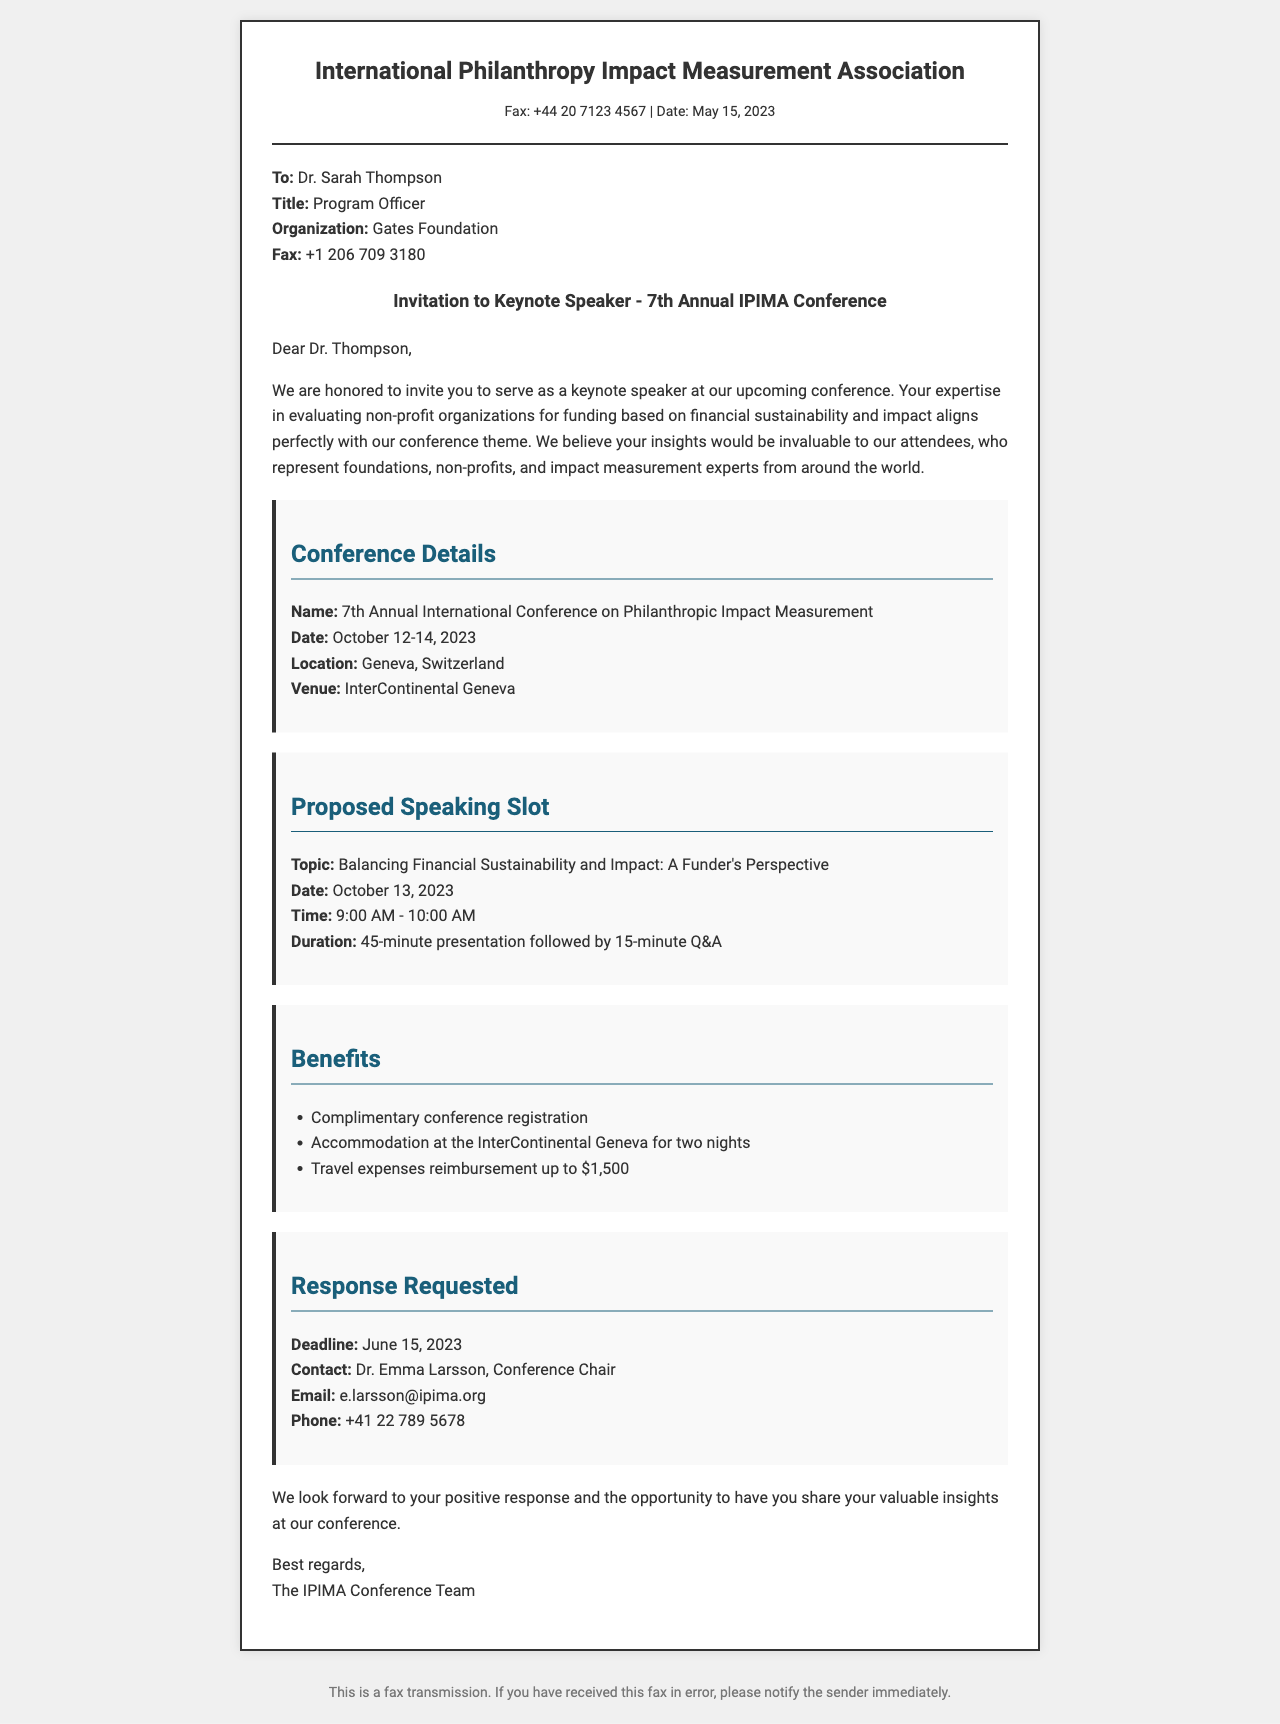What is the name of the conference? The document explicitly mentions the conference name in the conference details section, which is "7th Annual International Conference on Philanthropic Impact Measurement."
Answer: 7th Annual International Conference on Philanthropic Impact Measurement Who is the intended recipient of the fax? The recipient's information is provided at the beginning of the document, specifically mentioning "Dr. Sarah Thompson."
Answer: Dr. Sarah Thompson What date does the conference start? The start date of the conference is listed under the conference details section as "October 12, 2023."
Answer: October 12, 2023 What is the proposed topic for the keynote speech? The topic is stated in the speaking slot section as "Balancing Financial Sustainability and Impact: A Funder's Perspective."
Answer: Balancing Financial Sustainability and Impact: A Funder's Perspective What is the reimbursement amount for travel expenses? The benefits section mentions that the travel expenses will be reimbursed "up to $1,500."
Answer: up to $1,500 What is the deadline for response? The deadline date for response is mentioned in the response requested section, which is "June 15, 2023."
Answer: June 15, 2023 How long is the keynote presentation supposed to last? The speaking slot section indicates the duration of the presentation is "45-minute presentation followed by 15-minute Q&A," making it a total of one hour.
Answer: 45 minutes What type of document is this? The document serves as an invitation and is presented in the format of a fax, as indicated in the header.
Answer: Fax invitation 